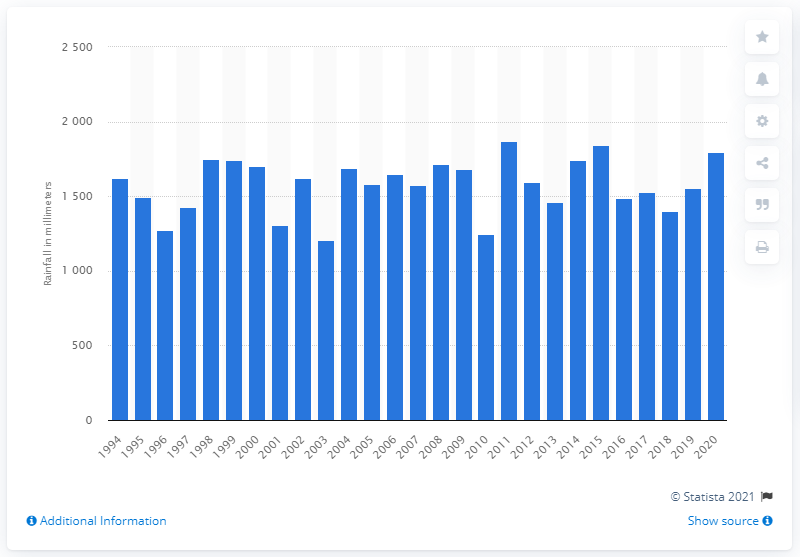Mention a couple of crucial points in this snapshot. Scotland's annual rainfall began to vary in 1994. 